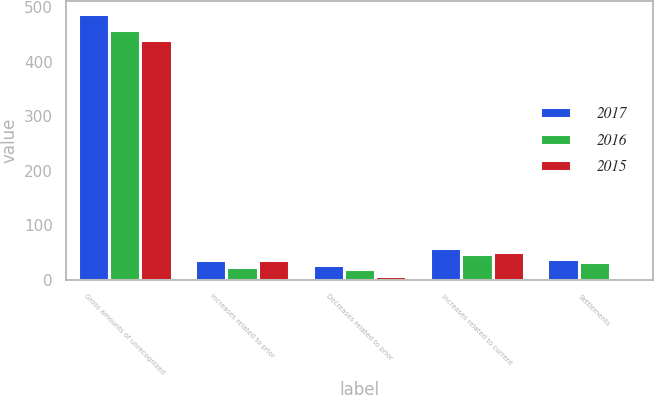Convert chart to OTSL. <chart><loc_0><loc_0><loc_500><loc_500><stacked_bar_chart><ecel><fcel>Gross amounts of unrecognized<fcel>Increases related to prior<fcel>Decreases related to prior<fcel>Increases related to current<fcel>Settlements<nl><fcel>2017<fcel>487<fcel>37<fcel>28<fcel>58<fcel>38<nl><fcel>2016<fcel>458<fcel>24<fcel>20<fcel>47<fcel>33<nl><fcel>2015<fcel>440<fcel>36<fcel>8<fcel>51<fcel>6<nl></chart> 